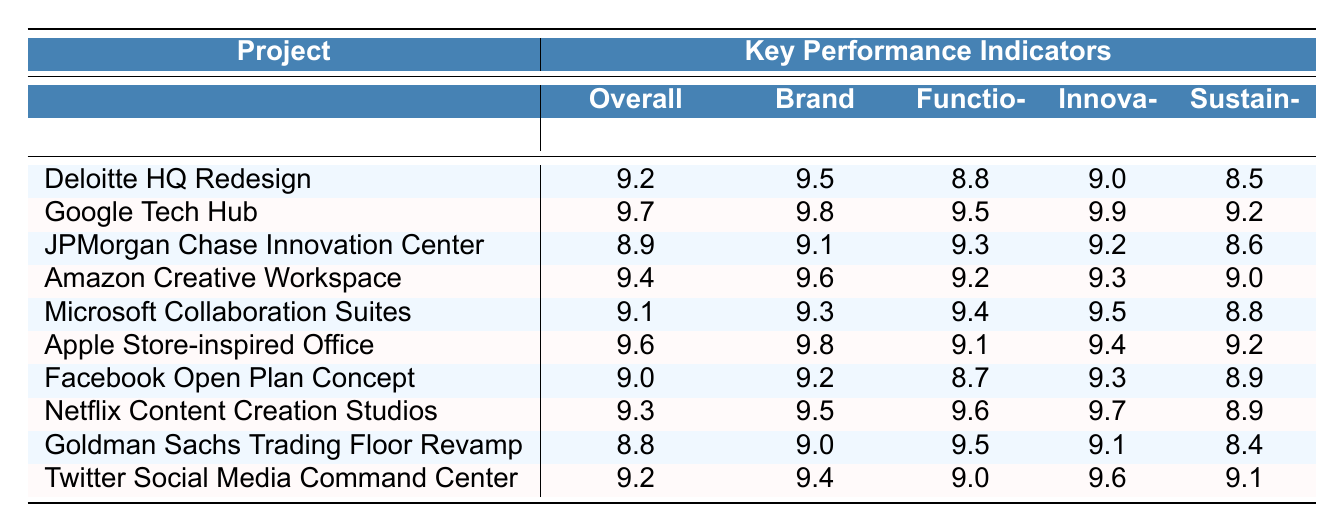What is the overall satisfaction rating for the Google Tech Hub project? According to the table, the rating for overall satisfaction for the Google Tech Hub is listed as 9.7.
Answer: 9.7 Which project received the lowest score in the sustainability criteria? The sustainability ratings for each project were examined, and the lowest score is 8.4, corresponding to the Goldman Sachs Trading Floor Revamp.
Answer: Goldman Sachs Trading Floor Revamp What is the average innovation integration rating across all projects? The innovation integration ratings are 9.0, 9.9, 9.2, 9.3, 9.5, 9.4, 9.3, 9.7, 9.1, and 9.6. Summing these numbers gives 94.6, and dividing by 10 (the number of projects) results in an average of 9.46.
Answer: 9.46 Did the Apple Store-inspired Office rate higher in employee comfort than the Facebook Open Plan Concept? The Apple Store-inspired Office has a score of 9.4 for employee comfort, while the Facebook Open Plan Concept has a score of 8.9. Since 9.4 is greater than 8.9, the Apple Store-inspired Office indeed rated higher.
Answer: Yes Which project has the highest score for brand alignment? By reviewing the brand alignment ratings, the Google Tech Hub received a score of 9.8, which is the highest among all projects.
Answer: Google Tech Hub What is the difference between the highest and lowest overall satisfaction ratings? The highest overall satisfaction rating is 9.7 from the Google Tech Hub, and the lowest is 8.8 from the Goldman Sachs Trading Floor Revamp. The difference is calculated as 9.7 - 8.8 = 0.9.
Answer: 0.9 Which project performed best in terms of aesthetics? The ratings for aesthetics were examined, and the highest score of 9.7 belongs to the Apple Store-inspired Office, indicating it performed best in this criterion.
Answer: Apple Store-inspired Office Can we conclude that the Amazon Creative Workspace is more cost-effective than the Goldman Sachs Trading Floor Revamp? The cost-effectiveness ratings reveal that Amazon Creative Workspace has a score of 9.0, while Goldman Sachs Trading Floor Revamp has a score of 8.7. Since 9.0 is greater than 8.7, the conclusion is correct.
Answer: Yes How many projects achieved an overall satisfaction rating of 9.0 or above? By counting the overall satisfaction ratings that are 9.0 or greater, we find a total of 7 projects.
Answer: 7 What overall satisfaction rating did the JPMorgan Chase Innovation Center receive, and how does it compare to the average overall satisfaction rating of 9.2? The JPMorgan Chase Innovation Center received an overall satisfaction rating of 8.9. Comparing this to the average of 9.2, it is clear that 8.9 is lower than 9.2.
Answer: Below average 